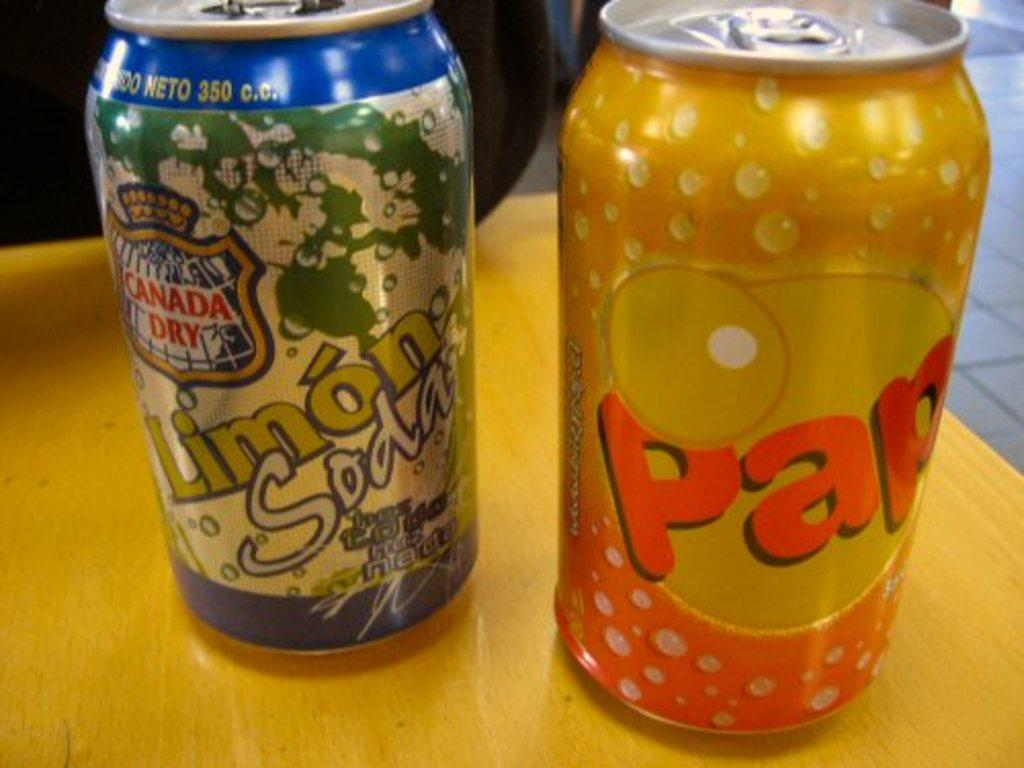Provide a one-sentence caption for the provided image. A can of Canada Dry Limon soda on the left and an orange can of pap soda on the right on a table. 